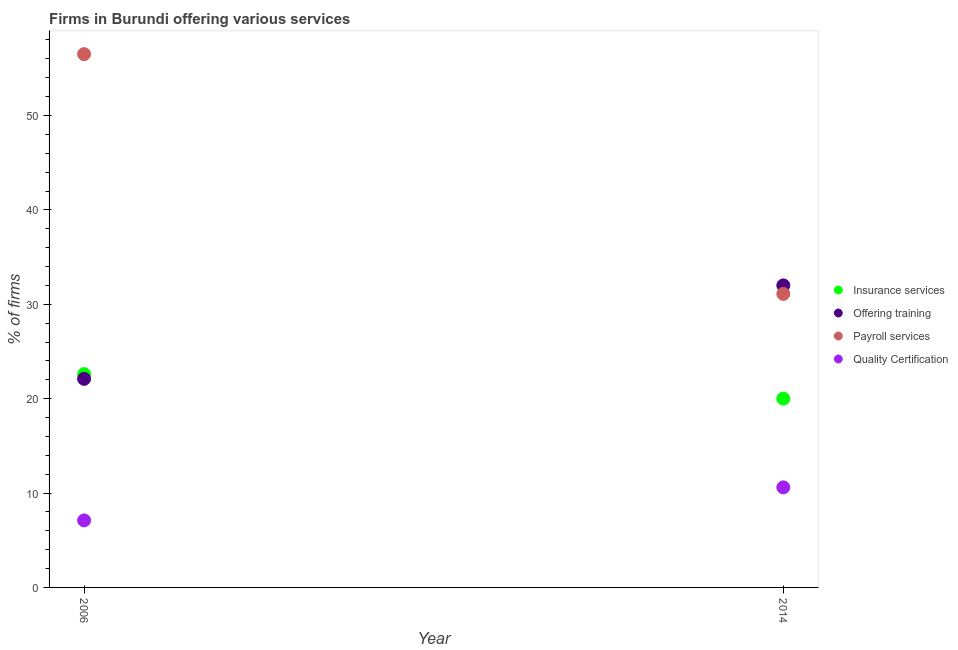What is the percentage of firms offering payroll services in 2014?
Offer a terse response. 31.1. Across all years, what is the maximum percentage of firms offering insurance services?
Your answer should be very brief. 22.6. In which year was the percentage of firms offering insurance services maximum?
Your answer should be compact. 2006. What is the total percentage of firms offering training in the graph?
Give a very brief answer. 54.1. What is the difference between the percentage of firms offering quality certification in 2006 and that in 2014?
Give a very brief answer. -3.5. What is the difference between the percentage of firms offering quality certification in 2014 and the percentage of firms offering insurance services in 2006?
Make the answer very short. -12. What is the average percentage of firms offering payroll services per year?
Your answer should be very brief. 43.8. In the year 2014, what is the difference between the percentage of firms offering quality certification and percentage of firms offering training?
Your response must be concise. -21.4. What is the ratio of the percentage of firms offering insurance services in 2006 to that in 2014?
Make the answer very short. 1.13. In how many years, is the percentage of firms offering training greater than the average percentage of firms offering training taken over all years?
Offer a terse response. 1. Is it the case that in every year, the sum of the percentage of firms offering insurance services and percentage of firms offering training is greater than the percentage of firms offering payroll services?
Offer a very short reply. No. Is the percentage of firms offering payroll services strictly greater than the percentage of firms offering training over the years?
Keep it short and to the point. No. Is the percentage of firms offering insurance services strictly less than the percentage of firms offering quality certification over the years?
Your answer should be compact. No. Are the values on the major ticks of Y-axis written in scientific E-notation?
Provide a short and direct response. No. Does the graph contain any zero values?
Your answer should be compact. No. Does the graph contain grids?
Make the answer very short. No. How many legend labels are there?
Offer a very short reply. 4. What is the title of the graph?
Make the answer very short. Firms in Burundi offering various services . Does "Primary education" appear as one of the legend labels in the graph?
Provide a succinct answer. No. What is the label or title of the Y-axis?
Provide a succinct answer. % of firms. What is the % of firms of Insurance services in 2006?
Provide a short and direct response. 22.6. What is the % of firms in Offering training in 2006?
Offer a terse response. 22.1. What is the % of firms in Payroll services in 2006?
Keep it short and to the point. 56.5. What is the % of firms in Quality Certification in 2006?
Your response must be concise. 7.1. What is the % of firms in Payroll services in 2014?
Your answer should be compact. 31.1. What is the % of firms in Quality Certification in 2014?
Your answer should be very brief. 10.6. Across all years, what is the maximum % of firms of Insurance services?
Your response must be concise. 22.6. Across all years, what is the maximum % of firms of Payroll services?
Give a very brief answer. 56.5. Across all years, what is the maximum % of firms of Quality Certification?
Your response must be concise. 10.6. Across all years, what is the minimum % of firms in Insurance services?
Make the answer very short. 20. Across all years, what is the minimum % of firms in Offering training?
Your answer should be compact. 22.1. Across all years, what is the minimum % of firms in Payroll services?
Offer a terse response. 31.1. What is the total % of firms of Insurance services in the graph?
Keep it short and to the point. 42.6. What is the total % of firms in Offering training in the graph?
Offer a terse response. 54.1. What is the total % of firms in Payroll services in the graph?
Keep it short and to the point. 87.6. What is the difference between the % of firms of Offering training in 2006 and that in 2014?
Your response must be concise. -9.9. What is the difference between the % of firms in Payroll services in 2006 and that in 2014?
Your answer should be compact. 25.4. What is the difference between the % of firms of Quality Certification in 2006 and that in 2014?
Your response must be concise. -3.5. What is the difference between the % of firms in Insurance services in 2006 and the % of firms in Payroll services in 2014?
Offer a very short reply. -8.5. What is the difference between the % of firms of Insurance services in 2006 and the % of firms of Quality Certification in 2014?
Provide a succinct answer. 12. What is the difference between the % of firms in Payroll services in 2006 and the % of firms in Quality Certification in 2014?
Your response must be concise. 45.9. What is the average % of firms in Insurance services per year?
Your response must be concise. 21.3. What is the average % of firms in Offering training per year?
Your answer should be very brief. 27.05. What is the average % of firms in Payroll services per year?
Make the answer very short. 43.8. What is the average % of firms in Quality Certification per year?
Provide a succinct answer. 8.85. In the year 2006, what is the difference between the % of firms in Insurance services and % of firms in Payroll services?
Ensure brevity in your answer.  -33.9. In the year 2006, what is the difference between the % of firms of Offering training and % of firms of Payroll services?
Your answer should be compact. -34.4. In the year 2006, what is the difference between the % of firms of Offering training and % of firms of Quality Certification?
Offer a terse response. 15. In the year 2006, what is the difference between the % of firms of Payroll services and % of firms of Quality Certification?
Keep it short and to the point. 49.4. In the year 2014, what is the difference between the % of firms of Insurance services and % of firms of Offering training?
Provide a succinct answer. -12. In the year 2014, what is the difference between the % of firms in Offering training and % of firms in Payroll services?
Make the answer very short. 0.9. In the year 2014, what is the difference between the % of firms of Offering training and % of firms of Quality Certification?
Your answer should be very brief. 21.4. What is the ratio of the % of firms of Insurance services in 2006 to that in 2014?
Offer a terse response. 1.13. What is the ratio of the % of firms of Offering training in 2006 to that in 2014?
Your answer should be compact. 0.69. What is the ratio of the % of firms in Payroll services in 2006 to that in 2014?
Provide a succinct answer. 1.82. What is the ratio of the % of firms of Quality Certification in 2006 to that in 2014?
Ensure brevity in your answer.  0.67. What is the difference between the highest and the second highest % of firms in Payroll services?
Ensure brevity in your answer.  25.4. What is the difference between the highest and the second highest % of firms of Quality Certification?
Provide a succinct answer. 3.5. What is the difference between the highest and the lowest % of firms of Insurance services?
Your response must be concise. 2.6. What is the difference between the highest and the lowest % of firms in Offering training?
Keep it short and to the point. 9.9. What is the difference between the highest and the lowest % of firms of Payroll services?
Offer a terse response. 25.4. 